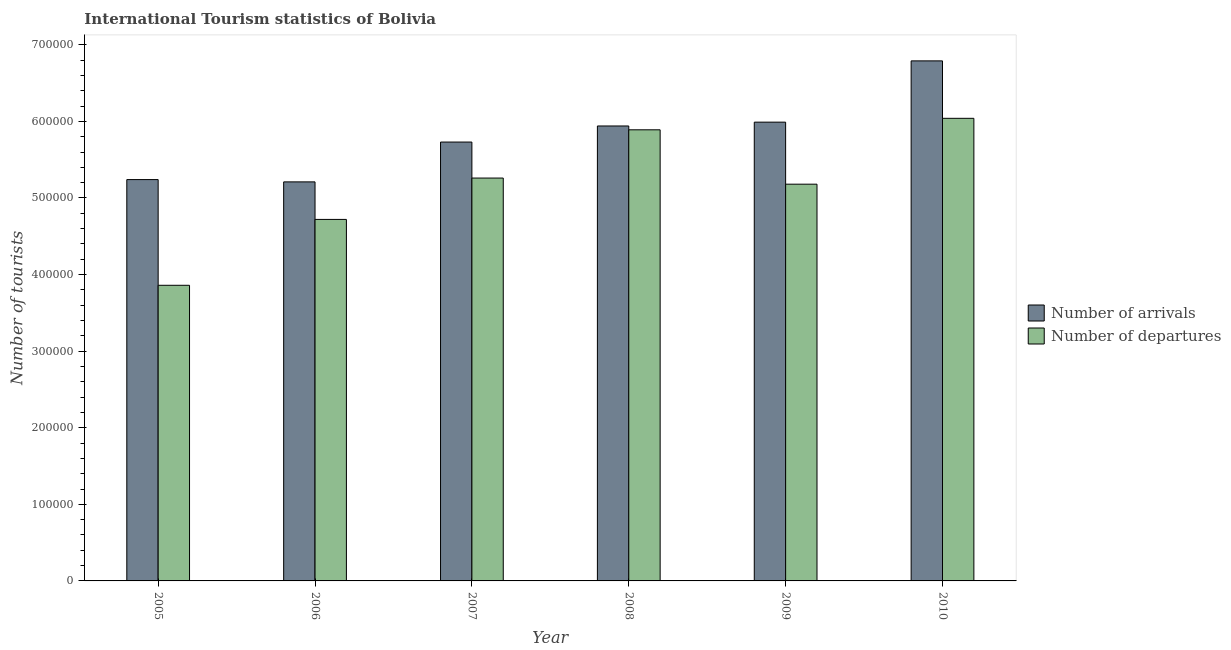How many groups of bars are there?
Provide a short and direct response. 6. Are the number of bars on each tick of the X-axis equal?
Offer a very short reply. Yes. How many bars are there on the 4th tick from the left?
Provide a succinct answer. 2. How many bars are there on the 6th tick from the right?
Give a very brief answer. 2. What is the number of tourist arrivals in 2006?
Give a very brief answer. 5.21e+05. Across all years, what is the maximum number of tourist departures?
Make the answer very short. 6.04e+05. Across all years, what is the minimum number of tourist departures?
Ensure brevity in your answer.  3.86e+05. In which year was the number of tourist departures maximum?
Keep it short and to the point. 2010. In which year was the number of tourist arrivals minimum?
Your answer should be compact. 2006. What is the total number of tourist arrivals in the graph?
Give a very brief answer. 3.49e+06. What is the difference between the number of tourist arrivals in 2005 and that in 2008?
Your answer should be compact. -7.00e+04. What is the difference between the number of tourist departures in 2006 and the number of tourist arrivals in 2007?
Provide a short and direct response. -5.40e+04. What is the average number of tourist departures per year?
Offer a very short reply. 5.16e+05. In the year 2007, what is the difference between the number of tourist arrivals and number of tourist departures?
Your answer should be compact. 0. What is the ratio of the number of tourist arrivals in 2008 to that in 2010?
Ensure brevity in your answer.  0.87. Is the difference between the number of tourist arrivals in 2005 and 2009 greater than the difference between the number of tourist departures in 2005 and 2009?
Keep it short and to the point. No. What is the difference between the highest and the second highest number of tourist departures?
Give a very brief answer. 1.50e+04. What is the difference between the highest and the lowest number of tourist arrivals?
Offer a very short reply. 1.58e+05. In how many years, is the number of tourist arrivals greater than the average number of tourist arrivals taken over all years?
Offer a very short reply. 3. Is the sum of the number of tourist departures in 2005 and 2007 greater than the maximum number of tourist arrivals across all years?
Give a very brief answer. Yes. What does the 2nd bar from the left in 2007 represents?
Make the answer very short. Number of departures. What does the 1st bar from the right in 2006 represents?
Offer a very short reply. Number of departures. Are all the bars in the graph horizontal?
Give a very brief answer. No. What is the difference between two consecutive major ticks on the Y-axis?
Keep it short and to the point. 1.00e+05. Are the values on the major ticks of Y-axis written in scientific E-notation?
Provide a short and direct response. No. Does the graph contain grids?
Give a very brief answer. No. What is the title of the graph?
Offer a terse response. International Tourism statistics of Bolivia. Does "Domestic liabilities" appear as one of the legend labels in the graph?
Ensure brevity in your answer.  No. What is the label or title of the Y-axis?
Keep it short and to the point. Number of tourists. What is the Number of tourists of Number of arrivals in 2005?
Your answer should be compact. 5.24e+05. What is the Number of tourists of Number of departures in 2005?
Provide a succinct answer. 3.86e+05. What is the Number of tourists of Number of arrivals in 2006?
Your answer should be compact. 5.21e+05. What is the Number of tourists of Number of departures in 2006?
Offer a terse response. 4.72e+05. What is the Number of tourists in Number of arrivals in 2007?
Your answer should be very brief. 5.73e+05. What is the Number of tourists in Number of departures in 2007?
Ensure brevity in your answer.  5.26e+05. What is the Number of tourists in Number of arrivals in 2008?
Your answer should be very brief. 5.94e+05. What is the Number of tourists of Number of departures in 2008?
Your answer should be compact. 5.89e+05. What is the Number of tourists of Number of arrivals in 2009?
Your answer should be very brief. 5.99e+05. What is the Number of tourists of Number of departures in 2009?
Offer a terse response. 5.18e+05. What is the Number of tourists of Number of arrivals in 2010?
Keep it short and to the point. 6.79e+05. What is the Number of tourists of Number of departures in 2010?
Keep it short and to the point. 6.04e+05. Across all years, what is the maximum Number of tourists in Number of arrivals?
Your answer should be compact. 6.79e+05. Across all years, what is the maximum Number of tourists of Number of departures?
Offer a very short reply. 6.04e+05. Across all years, what is the minimum Number of tourists in Number of arrivals?
Keep it short and to the point. 5.21e+05. Across all years, what is the minimum Number of tourists in Number of departures?
Your answer should be very brief. 3.86e+05. What is the total Number of tourists in Number of arrivals in the graph?
Provide a short and direct response. 3.49e+06. What is the total Number of tourists in Number of departures in the graph?
Offer a terse response. 3.10e+06. What is the difference between the Number of tourists in Number of arrivals in 2005 and that in 2006?
Your answer should be compact. 3000. What is the difference between the Number of tourists of Number of departures in 2005 and that in 2006?
Ensure brevity in your answer.  -8.60e+04. What is the difference between the Number of tourists of Number of arrivals in 2005 and that in 2007?
Provide a short and direct response. -4.90e+04. What is the difference between the Number of tourists of Number of departures in 2005 and that in 2007?
Provide a succinct answer. -1.40e+05. What is the difference between the Number of tourists in Number of arrivals in 2005 and that in 2008?
Offer a terse response. -7.00e+04. What is the difference between the Number of tourists of Number of departures in 2005 and that in 2008?
Your answer should be very brief. -2.03e+05. What is the difference between the Number of tourists of Number of arrivals in 2005 and that in 2009?
Offer a very short reply. -7.50e+04. What is the difference between the Number of tourists in Number of departures in 2005 and that in 2009?
Offer a terse response. -1.32e+05. What is the difference between the Number of tourists of Number of arrivals in 2005 and that in 2010?
Give a very brief answer. -1.55e+05. What is the difference between the Number of tourists of Number of departures in 2005 and that in 2010?
Your response must be concise. -2.18e+05. What is the difference between the Number of tourists of Number of arrivals in 2006 and that in 2007?
Your answer should be compact. -5.20e+04. What is the difference between the Number of tourists of Number of departures in 2006 and that in 2007?
Your answer should be compact. -5.40e+04. What is the difference between the Number of tourists in Number of arrivals in 2006 and that in 2008?
Your answer should be very brief. -7.30e+04. What is the difference between the Number of tourists in Number of departures in 2006 and that in 2008?
Provide a succinct answer. -1.17e+05. What is the difference between the Number of tourists of Number of arrivals in 2006 and that in 2009?
Give a very brief answer. -7.80e+04. What is the difference between the Number of tourists of Number of departures in 2006 and that in 2009?
Keep it short and to the point. -4.60e+04. What is the difference between the Number of tourists of Number of arrivals in 2006 and that in 2010?
Your answer should be compact. -1.58e+05. What is the difference between the Number of tourists of Number of departures in 2006 and that in 2010?
Your response must be concise. -1.32e+05. What is the difference between the Number of tourists of Number of arrivals in 2007 and that in 2008?
Your answer should be compact. -2.10e+04. What is the difference between the Number of tourists of Number of departures in 2007 and that in 2008?
Provide a succinct answer. -6.30e+04. What is the difference between the Number of tourists in Number of arrivals in 2007 and that in 2009?
Make the answer very short. -2.60e+04. What is the difference between the Number of tourists of Number of departures in 2007 and that in 2009?
Keep it short and to the point. 8000. What is the difference between the Number of tourists of Number of arrivals in 2007 and that in 2010?
Make the answer very short. -1.06e+05. What is the difference between the Number of tourists in Number of departures in 2007 and that in 2010?
Your response must be concise. -7.80e+04. What is the difference between the Number of tourists of Number of arrivals in 2008 and that in 2009?
Provide a short and direct response. -5000. What is the difference between the Number of tourists of Number of departures in 2008 and that in 2009?
Give a very brief answer. 7.10e+04. What is the difference between the Number of tourists in Number of arrivals in 2008 and that in 2010?
Your response must be concise. -8.50e+04. What is the difference between the Number of tourists of Number of departures in 2008 and that in 2010?
Ensure brevity in your answer.  -1.50e+04. What is the difference between the Number of tourists in Number of arrivals in 2009 and that in 2010?
Ensure brevity in your answer.  -8.00e+04. What is the difference between the Number of tourists of Number of departures in 2009 and that in 2010?
Provide a succinct answer. -8.60e+04. What is the difference between the Number of tourists of Number of arrivals in 2005 and the Number of tourists of Number of departures in 2006?
Your response must be concise. 5.20e+04. What is the difference between the Number of tourists of Number of arrivals in 2005 and the Number of tourists of Number of departures in 2007?
Offer a very short reply. -2000. What is the difference between the Number of tourists in Number of arrivals in 2005 and the Number of tourists in Number of departures in 2008?
Keep it short and to the point. -6.50e+04. What is the difference between the Number of tourists of Number of arrivals in 2005 and the Number of tourists of Number of departures in 2009?
Provide a short and direct response. 6000. What is the difference between the Number of tourists in Number of arrivals in 2006 and the Number of tourists in Number of departures in 2007?
Provide a succinct answer. -5000. What is the difference between the Number of tourists of Number of arrivals in 2006 and the Number of tourists of Number of departures in 2008?
Your answer should be very brief. -6.80e+04. What is the difference between the Number of tourists in Number of arrivals in 2006 and the Number of tourists in Number of departures in 2009?
Make the answer very short. 3000. What is the difference between the Number of tourists in Number of arrivals in 2006 and the Number of tourists in Number of departures in 2010?
Your answer should be compact. -8.30e+04. What is the difference between the Number of tourists in Number of arrivals in 2007 and the Number of tourists in Number of departures in 2008?
Give a very brief answer. -1.60e+04. What is the difference between the Number of tourists of Number of arrivals in 2007 and the Number of tourists of Number of departures in 2009?
Your response must be concise. 5.50e+04. What is the difference between the Number of tourists in Number of arrivals in 2007 and the Number of tourists in Number of departures in 2010?
Provide a succinct answer. -3.10e+04. What is the difference between the Number of tourists of Number of arrivals in 2008 and the Number of tourists of Number of departures in 2009?
Give a very brief answer. 7.60e+04. What is the difference between the Number of tourists of Number of arrivals in 2008 and the Number of tourists of Number of departures in 2010?
Offer a terse response. -10000. What is the difference between the Number of tourists of Number of arrivals in 2009 and the Number of tourists of Number of departures in 2010?
Give a very brief answer. -5000. What is the average Number of tourists in Number of arrivals per year?
Ensure brevity in your answer.  5.82e+05. What is the average Number of tourists of Number of departures per year?
Your answer should be very brief. 5.16e+05. In the year 2005, what is the difference between the Number of tourists of Number of arrivals and Number of tourists of Number of departures?
Your answer should be very brief. 1.38e+05. In the year 2006, what is the difference between the Number of tourists in Number of arrivals and Number of tourists in Number of departures?
Offer a terse response. 4.90e+04. In the year 2007, what is the difference between the Number of tourists in Number of arrivals and Number of tourists in Number of departures?
Your answer should be compact. 4.70e+04. In the year 2008, what is the difference between the Number of tourists of Number of arrivals and Number of tourists of Number of departures?
Ensure brevity in your answer.  5000. In the year 2009, what is the difference between the Number of tourists of Number of arrivals and Number of tourists of Number of departures?
Provide a succinct answer. 8.10e+04. In the year 2010, what is the difference between the Number of tourists in Number of arrivals and Number of tourists in Number of departures?
Offer a terse response. 7.50e+04. What is the ratio of the Number of tourists of Number of departures in 2005 to that in 2006?
Your response must be concise. 0.82. What is the ratio of the Number of tourists in Number of arrivals in 2005 to that in 2007?
Provide a succinct answer. 0.91. What is the ratio of the Number of tourists of Number of departures in 2005 to that in 2007?
Offer a terse response. 0.73. What is the ratio of the Number of tourists in Number of arrivals in 2005 to that in 2008?
Ensure brevity in your answer.  0.88. What is the ratio of the Number of tourists of Number of departures in 2005 to that in 2008?
Your answer should be very brief. 0.66. What is the ratio of the Number of tourists in Number of arrivals in 2005 to that in 2009?
Give a very brief answer. 0.87. What is the ratio of the Number of tourists of Number of departures in 2005 to that in 2009?
Provide a short and direct response. 0.75. What is the ratio of the Number of tourists in Number of arrivals in 2005 to that in 2010?
Provide a short and direct response. 0.77. What is the ratio of the Number of tourists in Number of departures in 2005 to that in 2010?
Offer a very short reply. 0.64. What is the ratio of the Number of tourists in Number of arrivals in 2006 to that in 2007?
Your response must be concise. 0.91. What is the ratio of the Number of tourists of Number of departures in 2006 to that in 2007?
Your answer should be very brief. 0.9. What is the ratio of the Number of tourists of Number of arrivals in 2006 to that in 2008?
Offer a very short reply. 0.88. What is the ratio of the Number of tourists of Number of departures in 2006 to that in 2008?
Offer a very short reply. 0.8. What is the ratio of the Number of tourists in Number of arrivals in 2006 to that in 2009?
Make the answer very short. 0.87. What is the ratio of the Number of tourists of Number of departures in 2006 to that in 2009?
Your answer should be very brief. 0.91. What is the ratio of the Number of tourists in Number of arrivals in 2006 to that in 2010?
Provide a short and direct response. 0.77. What is the ratio of the Number of tourists in Number of departures in 2006 to that in 2010?
Offer a terse response. 0.78. What is the ratio of the Number of tourists in Number of arrivals in 2007 to that in 2008?
Provide a short and direct response. 0.96. What is the ratio of the Number of tourists of Number of departures in 2007 to that in 2008?
Your answer should be very brief. 0.89. What is the ratio of the Number of tourists in Number of arrivals in 2007 to that in 2009?
Your answer should be very brief. 0.96. What is the ratio of the Number of tourists of Number of departures in 2007 to that in 2009?
Your response must be concise. 1.02. What is the ratio of the Number of tourists in Number of arrivals in 2007 to that in 2010?
Keep it short and to the point. 0.84. What is the ratio of the Number of tourists in Number of departures in 2007 to that in 2010?
Your answer should be very brief. 0.87. What is the ratio of the Number of tourists of Number of departures in 2008 to that in 2009?
Your answer should be compact. 1.14. What is the ratio of the Number of tourists in Number of arrivals in 2008 to that in 2010?
Your answer should be compact. 0.87. What is the ratio of the Number of tourists in Number of departures in 2008 to that in 2010?
Your answer should be very brief. 0.98. What is the ratio of the Number of tourists of Number of arrivals in 2009 to that in 2010?
Provide a short and direct response. 0.88. What is the ratio of the Number of tourists of Number of departures in 2009 to that in 2010?
Offer a terse response. 0.86. What is the difference between the highest and the second highest Number of tourists in Number of arrivals?
Your answer should be very brief. 8.00e+04. What is the difference between the highest and the second highest Number of tourists of Number of departures?
Provide a short and direct response. 1.50e+04. What is the difference between the highest and the lowest Number of tourists of Number of arrivals?
Provide a succinct answer. 1.58e+05. What is the difference between the highest and the lowest Number of tourists of Number of departures?
Your answer should be compact. 2.18e+05. 